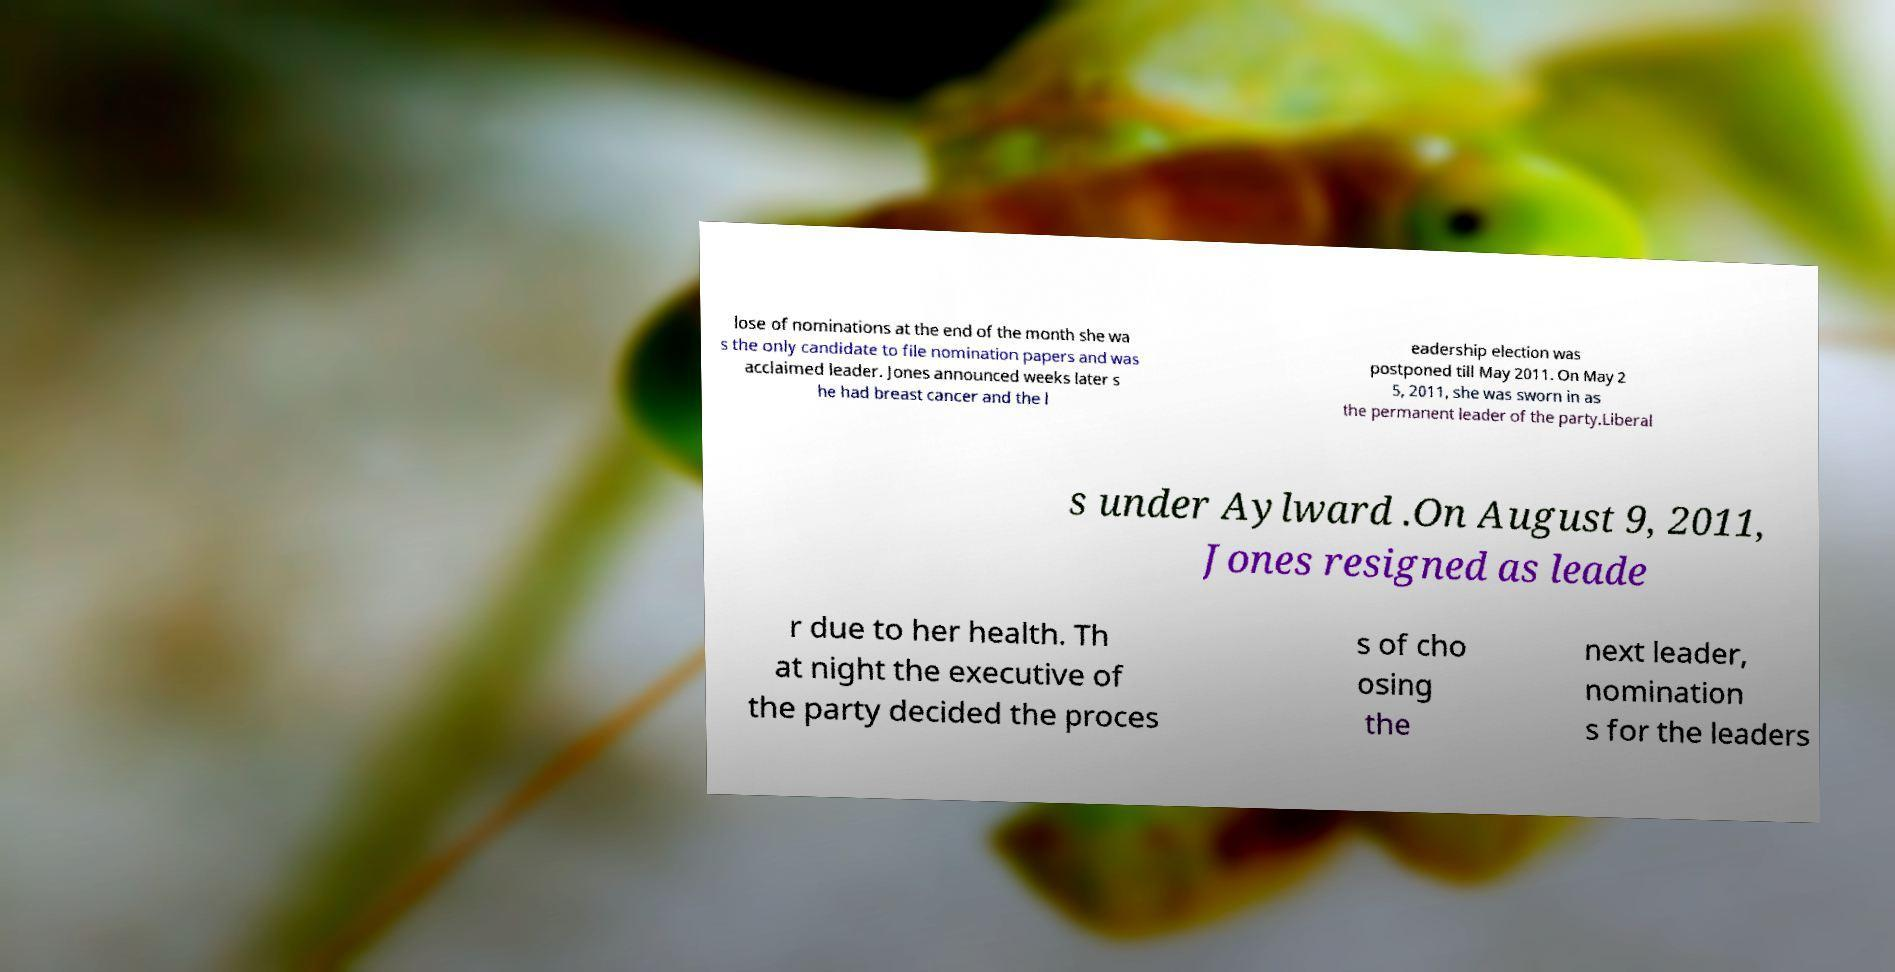Can you read and provide the text displayed in the image?This photo seems to have some interesting text. Can you extract and type it out for me? lose of nominations at the end of the month she wa s the only candidate to file nomination papers and was acclaimed leader. Jones announced weeks later s he had breast cancer and the l eadership election was postponed till May 2011. On May 2 5, 2011, she was sworn in as the permanent leader of the party.Liberal s under Aylward .On August 9, 2011, Jones resigned as leade r due to her health. Th at night the executive of the party decided the proces s of cho osing the next leader, nomination s for the leaders 